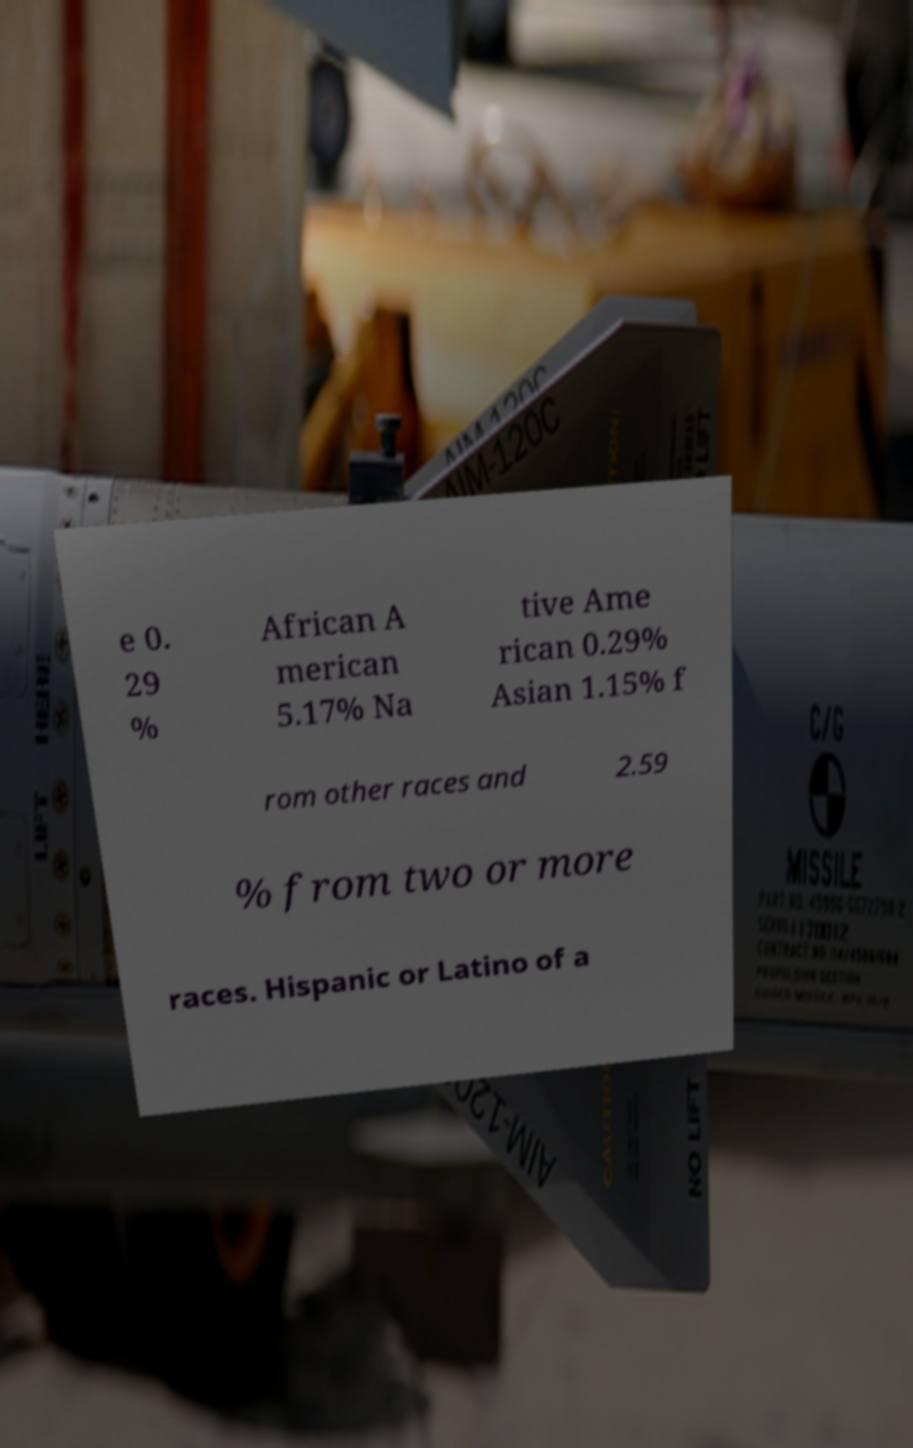Please identify and transcribe the text found in this image. e 0. 29 % African A merican 5.17% Na tive Ame rican 0.29% Asian 1.15% f rom other races and 2.59 % from two or more races. Hispanic or Latino of a 